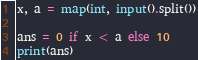Convert code to text. <code><loc_0><loc_0><loc_500><loc_500><_Python_>x, a = map(int, input().split())

ans = 0 if x < a else 10
print(ans)</code> 